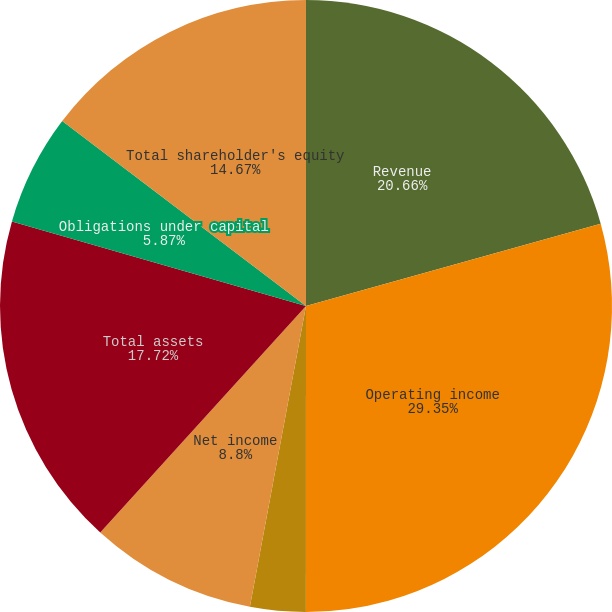Convert chart. <chart><loc_0><loc_0><loc_500><loc_500><pie_chart><fcel>Revenue<fcel>Operating income<fcel>Income before cumulative<fcel>Net income<fcel>Dividends per share<fcel>Total assets<fcel>Obligations under capital<fcel>Total shareholder's equity<nl><fcel>20.66%<fcel>29.34%<fcel>2.93%<fcel>8.8%<fcel>0.0%<fcel>17.72%<fcel>5.87%<fcel>14.67%<nl></chart> 